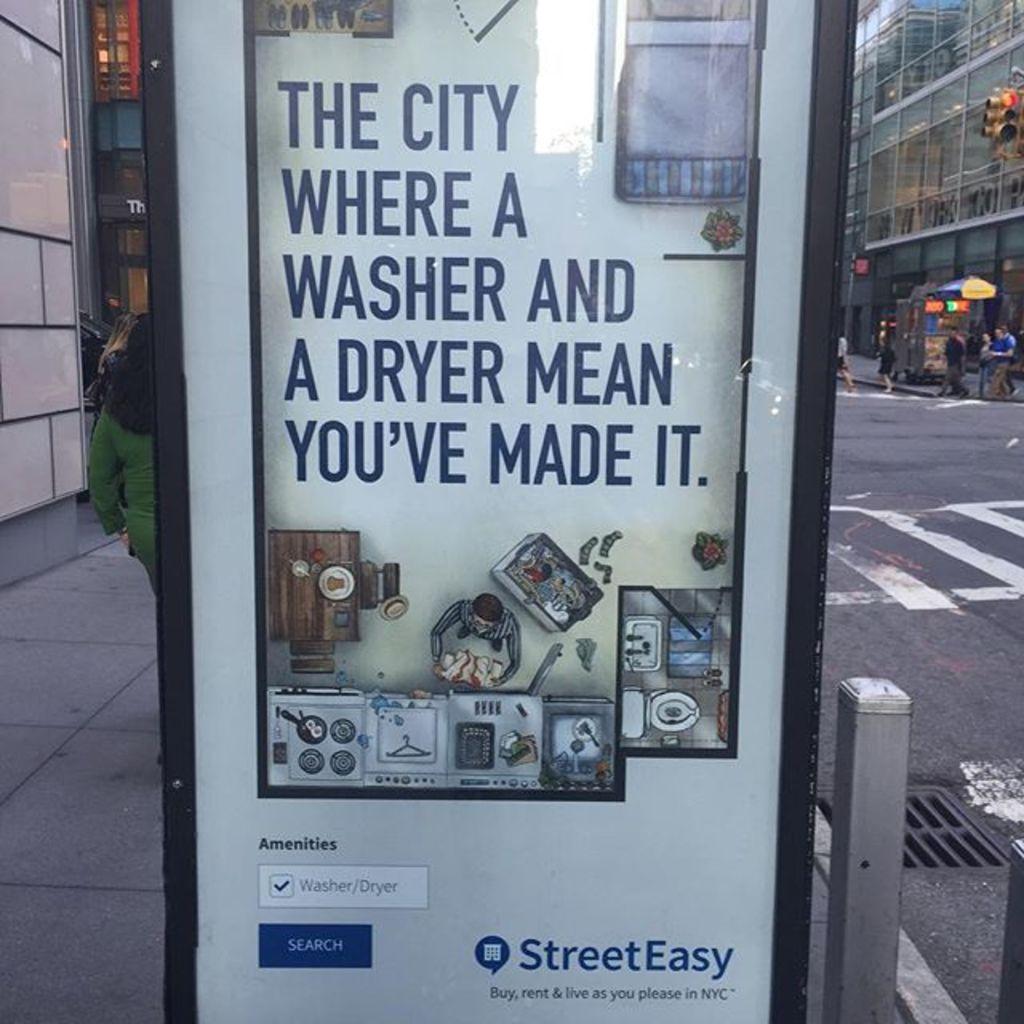What app is this advertising?
Provide a succinct answer. Streeteasy. What type of amenities are offered?
Your response must be concise. Washer and dryer. 